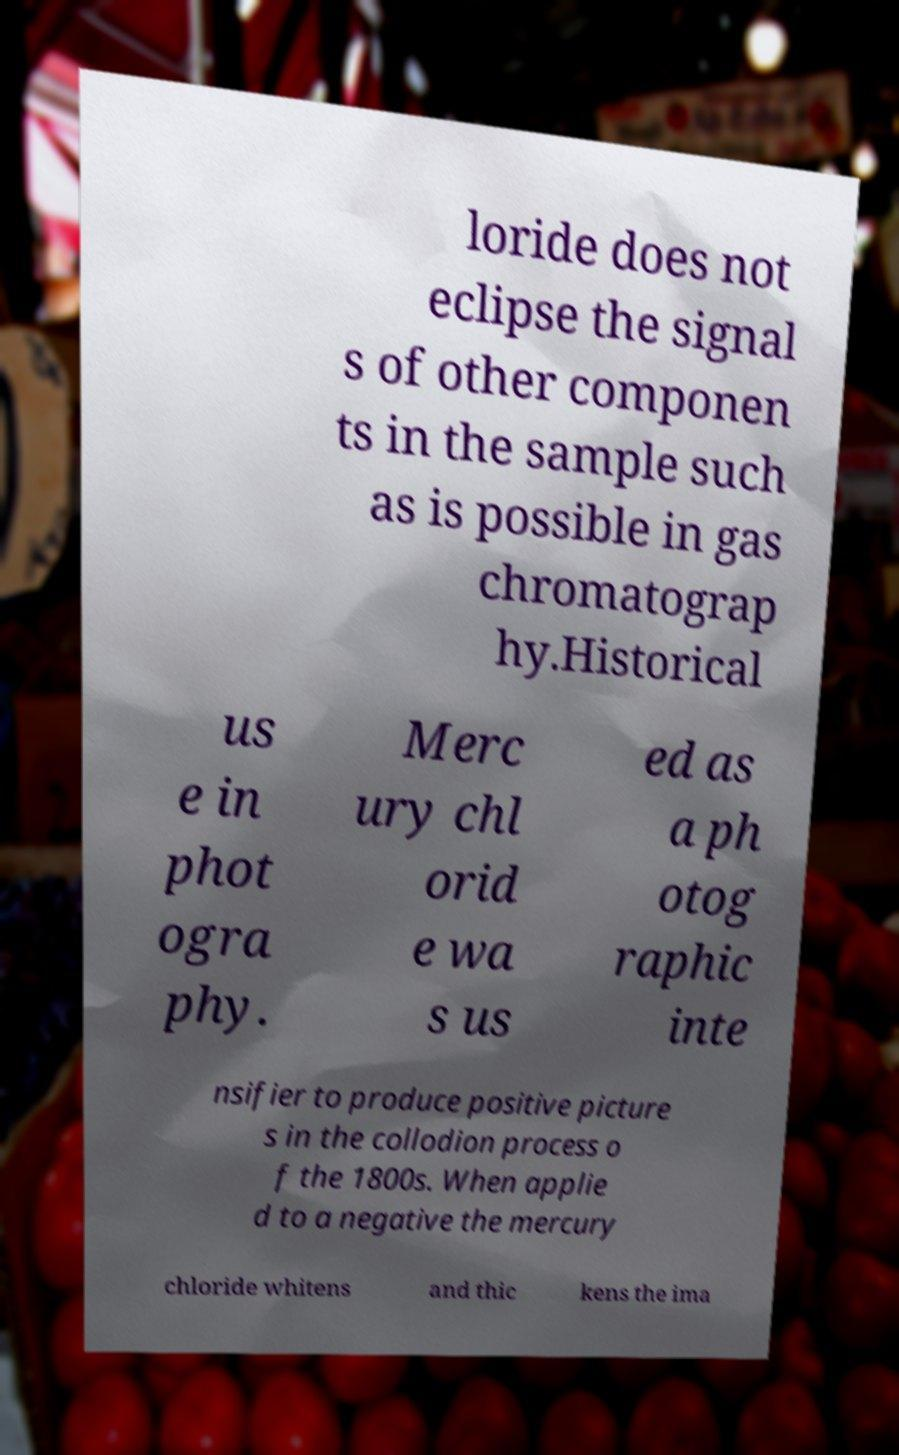Can you accurately transcribe the text from the provided image for me? loride does not eclipse the signal s of other componen ts in the sample such as is possible in gas chromatograp hy.Historical us e in phot ogra phy. Merc ury chl orid e wa s us ed as a ph otog raphic inte nsifier to produce positive picture s in the collodion process o f the 1800s. When applie d to a negative the mercury chloride whitens and thic kens the ima 